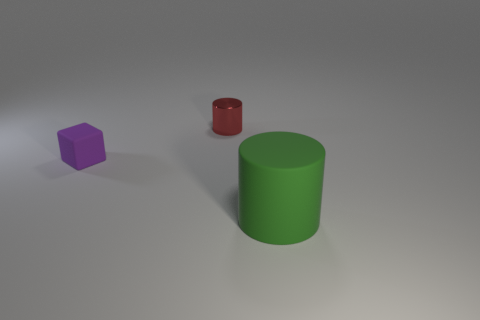There is a small object that is the same shape as the big green thing; what material is it?
Your answer should be very brief. Metal. What number of green things are behind the big green matte thing?
Your answer should be very brief. 0. There is a small object that is behind the matte object behind the large green rubber cylinder; are there any purple matte objects in front of it?
Your answer should be compact. Yes. Does the block have the same size as the green cylinder?
Ensure brevity in your answer.  No. Are there an equal number of matte things that are on the right side of the tiny red cylinder and big green matte things to the left of the rubber cylinder?
Give a very brief answer. No. There is a small object in front of the tiny red metal object; what shape is it?
Offer a very short reply. Cube. What is the shape of the metallic thing that is the same size as the purple cube?
Keep it short and to the point. Cylinder. The rubber object right of the small rubber cube on the left side of the cylinder that is behind the matte cylinder is what color?
Offer a terse response. Green. Is the green thing the same shape as the tiny rubber thing?
Keep it short and to the point. No. Are there an equal number of blocks to the right of the red metallic cylinder and blue rubber things?
Offer a very short reply. Yes. 